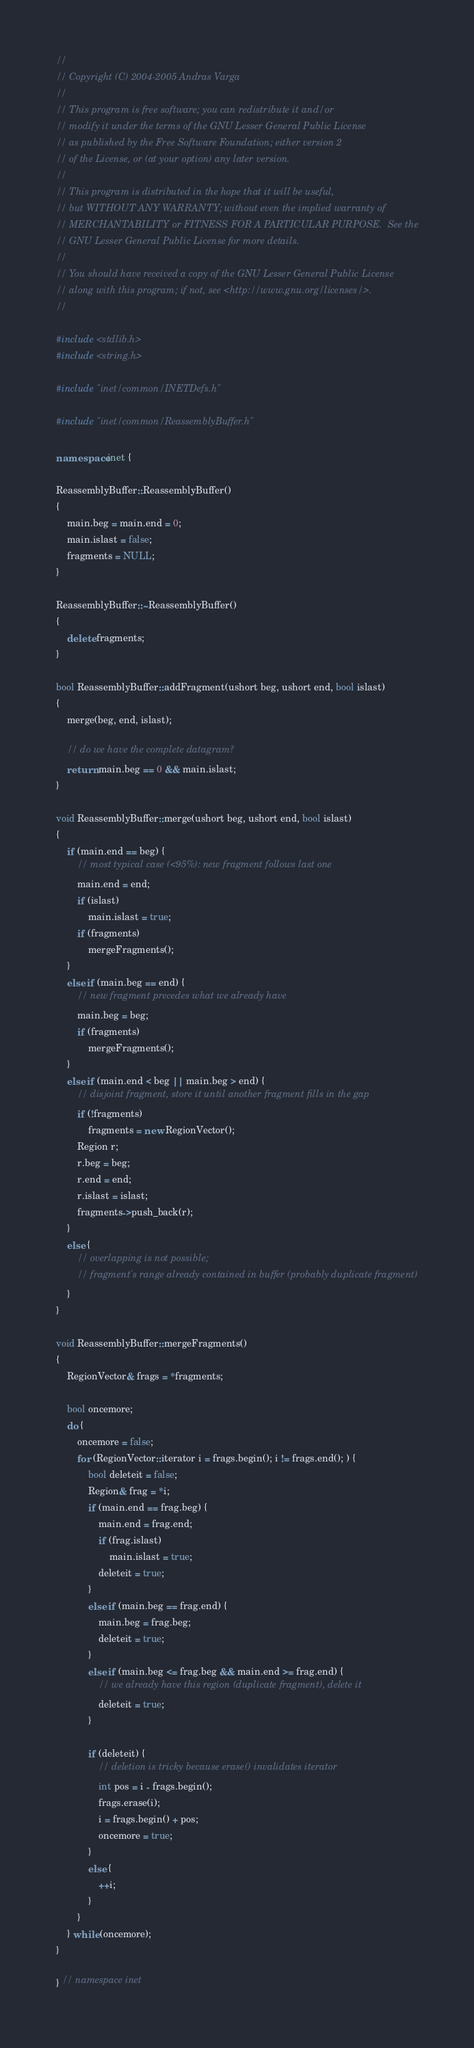Convert code to text. <code><loc_0><loc_0><loc_500><loc_500><_C++_>//
// Copyright (C) 2004-2005 Andras Varga
//
// This program is free software; you can redistribute it and/or
// modify it under the terms of the GNU Lesser General Public License
// as published by the Free Software Foundation; either version 2
// of the License, or (at your option) any later version.
//
// This program is distributed in the hope that it will be useful,
// but WITHOUT ANY WARRANTY; without even the implied warranty of
// MERCHANTABILITY or FITNESS FOR A PARTICULAR PURPOSE.  See the
// GNU Lesser General Public License for more details.
//
// You should have received a copy of the GNU Lesser General Public License
// along with this program; if not, see <http://www.gnu.org/licenses/>.
//

#include <stdlib.h>
#include <string.h>

#include "inet/common/INETDefs.h"

#include "inet/common/ReassemblyBuffer.h"

namespace inet {

ReassemblyBuffer::ReassemblyBuffer()
{
    main.beg = main.end = 0;
    main.islast = false;
    fragments = NULL;
}

ReassemblyBuffer::~ReassemblyBuffer()
{
    delete fragments;
}

bool ReassemblyBuffer::addFragment(ushort beg, ushort end, bool islast)
{
    merge(beg, end, islast);

    // do we have the complete datagram?
    return main.beg == 0 && main.islast;
}

void ReassemblyBuffer::merge(ushort beg, ushort end, bool islast)
{
    if (main.end == beg) {
        // most typical case (<95%): new fragment follows last one
        main.end = end;
        if (islast)
            main.islast = true;
        if (fragments)
            mergeFragments();
    }
    else if (main.beg == end) {
        // new fragment precedes what we already have
        main.beg = beg;
        if (fragments)
            mergeFragments();
    }
    else if (main.end < beg || main.beg > end) {
        // disjoint fragment, store it until another fragment fills in the gap
        if (!fragments)
            fragments = new RegionVector();
        Region r;
        r.beg = beg;
        r.end = end;
        r.islast = islast;
        fragments->push_back(r);
    }
    else {
        // overlapping is not possible;
        // fragment's range already contained in buffer (probably duplicate fragment)
    }
}

void ReassemblyBuffer::mergeFragments()
{
    RegionVector& frags = *fragments;

    bool oncemore;
    do {
        oncemore = false;
        for (RegionVector::iterator i = frags.begin(); i != frags.end(); ) {
            bool deleteit = false;
            Region& frag = *i;
            if (main.end == frag.beg) {
                main.end = frag.end;
                if (frag.islast)
                    main.islast = true;
                deleteit = true;
            }
            else if (main.beg == frag.end) {
                main.beg = frag.beg;
                deleteit = true;
            }
            else if (main.beg <= frag.beg && main.end >= frag.end) {
                // we already have this region (duplicate fragment), delete it
                deleteit = true;
            }

            if (deleteit) {
                // deletion is tricky because erase() invalidates iterator
                int pos = i - frags.begin();
                frags.erase(i);
                i = frags.begin() + pos;
                oncemore = true;
            }
            else {
                ++i;
            }
        }
    } while (oncemore);
}

} // namespace inet

</code> 